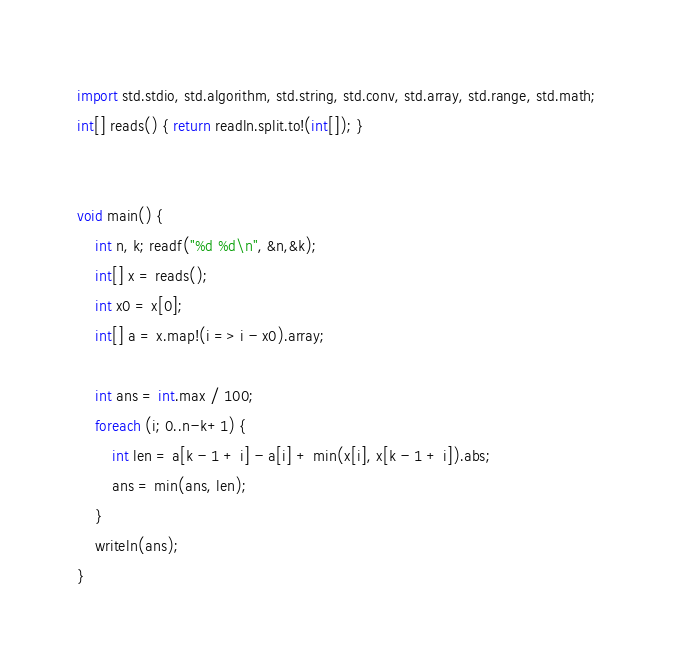Convert code to text. <code><loc_0><loc_0><loc_500><loc_500><_D_>import std.stdio, std.algorithm, std.string, std.conv, std.array, std.range, std.math;
int[] reads() { return readln.split.to!(int[]); }


void main() {
    int n, k; readf("%d %d\n", &n,&k);
    int[] x = reads();
    int x0 = x[0];
    int[] a = x.map!(i => i - x0).array;

    int ans = int.max / 100;
    foreach (i; 0..n-k+1) {
        int len = a[k - 1 + i] - a[i] + min(x[i], x[k - 1 + i]).abs;
        ans = min(ans, len);
    }
    writeln(ans);
}</code> 